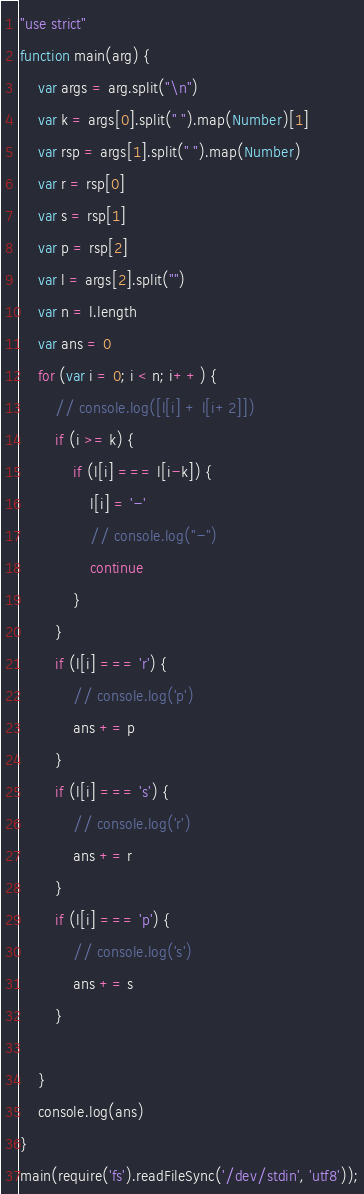<code> <loc_0><loc_0><loc_500><loc_500><_JavaScript_>"use strict"
function main(arg) {
    var args = arg.split("\n")
    var k = args[0].split(" ").map(Number)[1]
    var rsp = args[1].split(" ").map(Number)
    var r = rsp[0]
    var s = rsp[1]
    var p = rsp[2]
    var l = args[2].split("")
    var n = l.length
    var ans = 0
    for (var i = 0; i < n; i++) {
        // console.log([l[i] + l[i+2]])
        if (i >= k) {
            if (l[i] === l[i-k]) {
                l[i] = '-'
                // console.log("-")
                continue
            }
        }
        if (l[i] === 'r') {
            // console.log('p')
            ans += p
        }
        if (l[i] === 's') {
            // console.log('r')
            ans += r
        }
        if (l[i] === 'p') {
            // console.log('s')
            ans += s
        }
        
    }
    console.log(ans)
}
main(require('fs').readFileSync('/dev/stdin', 'utf8'));</code> 